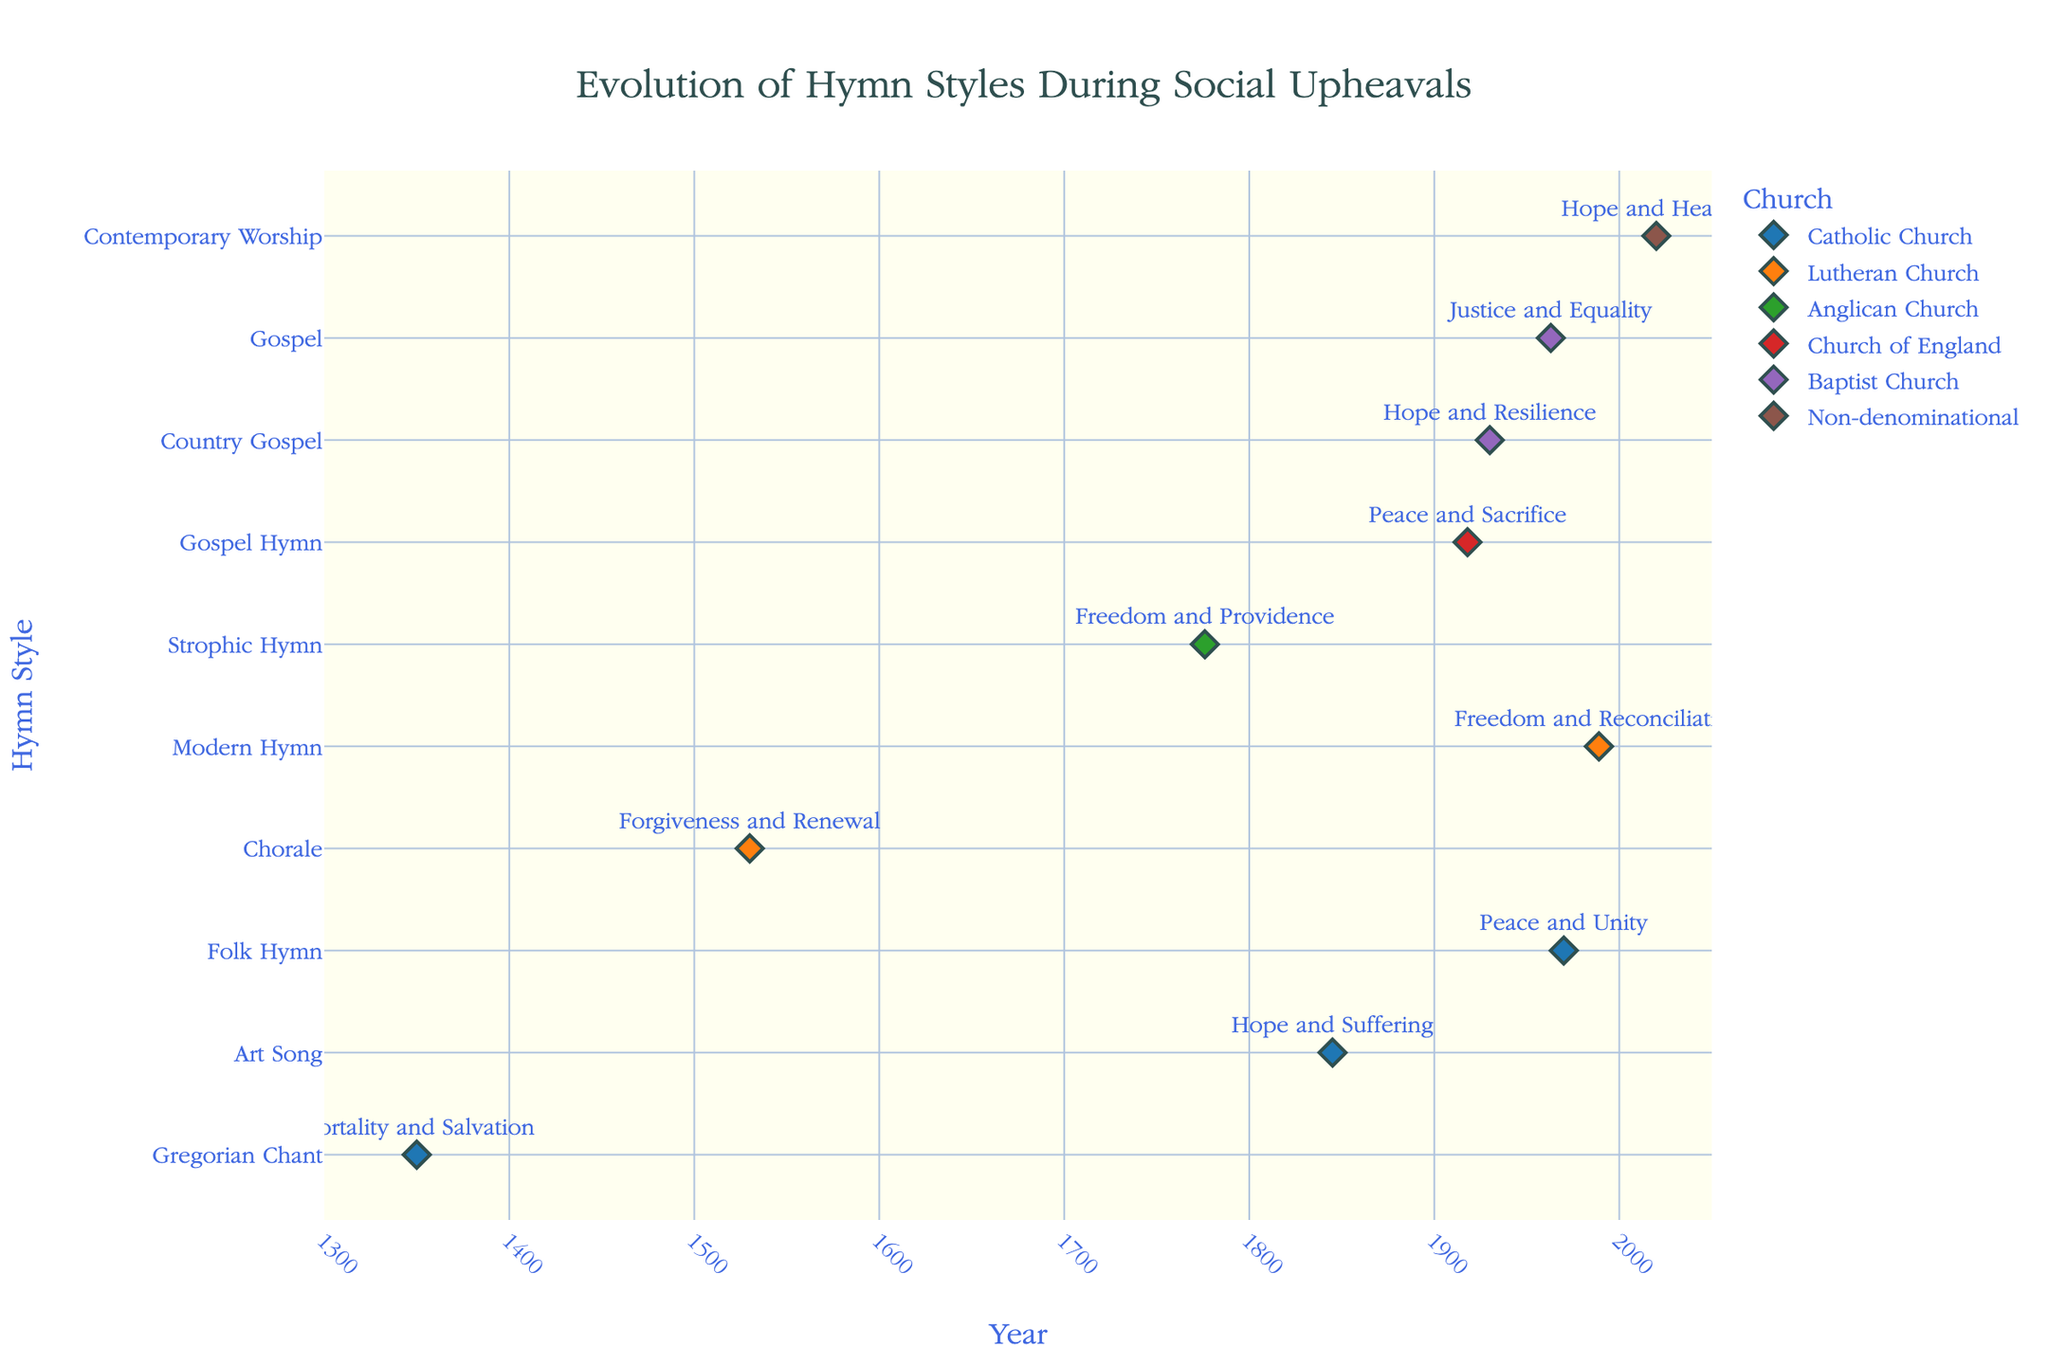What is the title of the plot? The plot's title appears at the top and reads: "Evolution of Hymn Styles During Social Upheavals."
Answer: Evolution of Hymn Styles During Social Upheavals Which church had its hymn style change to 'Gospel' during the Civil Rights Movement? The label for the year 1963 indicates that the 'Baptist Church' changed its hymn style to 'Gospel' during the Civil Rights Movement.
Answer: Baptist Church Which historical period corresponds to the 'Gregorian Chant' style? The 'Gregorian Chant' style is linked to the Middle Ages, specifically the year 1350, as indicated by the plot.
Answer: Middle Ages During which year did the 'Lutheran Church' experience a hymn style change to 'Modern Hymn'? The 'Modern Hymn' style is mapped to the year 1989, associated with the 'Lutheran Church.'
Answer: 1989 How many different churches are represented in the plot? The legend lists the unique churches, and counting these provides the answer: Catholic Church, Lutheran Church, Anglican Church, Church of England, Baptist Church, and Non-denominational. There are six different churches represented.
Answer: Six What is the average year of the hymn style changes plotted for the 'Catholic Church'? The 'Catholic Church' hymn style changes occur in the years 1350, 1845, and 1970. To find the average: (1350 + 1845 + 1970) / 3 equals 1721.67.
Answer: 1721.67 Compare the hymn themes of the 'Anglican Church' during the American Revolution and the 'Church of England' during World War I. Are they related? The 'Anglican Church' during the American Revolution has the theme 'Freedom and Providence,' while the 'Church of England' during World War I has the theme 'Peace and Sacrifice.' These themes both deal with positive human conditions (freedom/providence vs. peace/sacrifice) and could be seen as related through their focus on societal values and human experience.
Answer: Related through societal values Which event correlates with the hymn theme 'Justice and Equality'? The year 1963 shows the hymn theme 'Justice and Equality,' which is related to the 'March on Washington' event, linked to the 'Baptist Church.'
Answer: March on Washington Identify the historical period in which the 'Art Song' style emerged and describe the corresponding social upheaval. The 'Art Song' style appears in the Industrial Revolution period during the Irish Potato Famine of 1845.
Answer: Industrial Revolution, Irish Potato Famine 